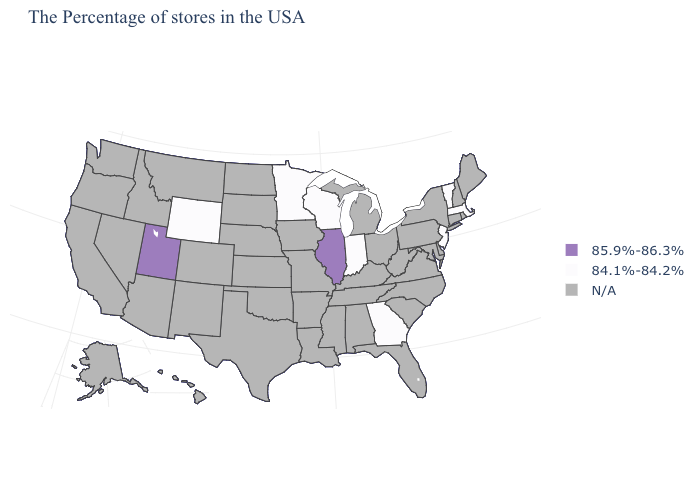What is the highest value in the USA?
Short answer required. 85.9%-86.3%. What is the value of Hawaii?
Write a very short answer. N/A. How many symbols are there in the legend?
Answer briefly. 3. Which states have the lowest value in the USA?
Write a very short answer. Massachusetts, Vermont, New Jersey, Georgia, Indiana, Wisconsin, Minnesota, Wyoming. Which states hav the highest value in the Northeast?
Give a very brief answer. Massachusetts, Vermont, New Jersey. Which states hav the highest value in the West?
Be succinct. Utah. Is the legend a continuous bar?
Give a very brief answer. No. What is the value of Ohio?
Give a very brief answer. N/A. What is the highest value in the West ?
Concise answer only. 85.9%-86.3%. Which states have the lowest value in the Northeast?
Keep it brief. Massachusetts, Vermont, New Jersey. What is the lowest value in states that border Michigan?
Quick response, please. 84.1%-84.2%. What is the value of Kentucky?
Short answer required. N/A. Does Utah have the lowest value in the USA?
Write a very short answer. No. What is the value of Mississippi?
Short answer required. N/A. Does Indiana have the lowest value in the USA?
Answer briefly. Yes. 